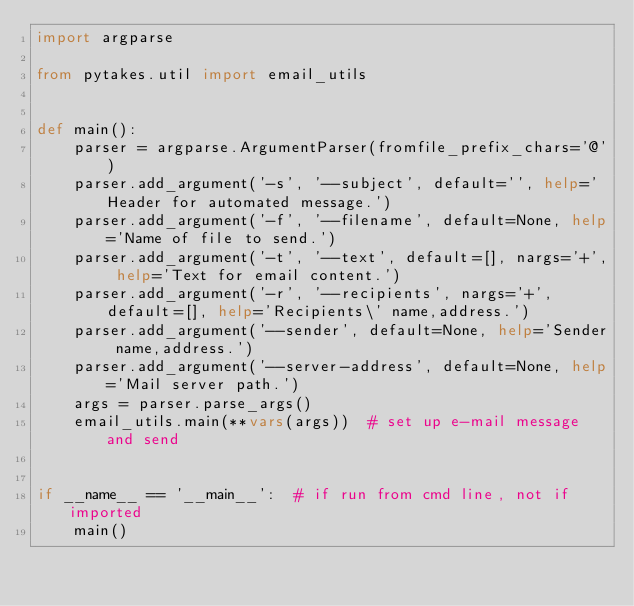Convert code to text. <code><loc_0><loc_0><loc_500><loc_500><_Python_>import argparse

from pytakes.util import email_utils


def main():
    parser = argparse.ArgumentParser(fromfile_prefix_chars='@')
    parser.add_argument('-s', '--subject', default='', help='Header for automated message.')
    parser.add_argument('-f', '--filename', default=None, help='Name of file to send.')
    parser.add_argument('-t', '--text', default=[], nargs='+', help='Text for email content.')
    parser.add_argument('-r', '--recipients', nargs='+', default=[], help='Recipients\' name,address.')
    parser.add_argument('--sender', default=None, help='Sender name,address.')
    parser.add_argument('--server-address', default=None, help='Mail server path.')
    args = parser.parse_args()
    email_utils.main(**vars(args))  # set up e-mail message and send


if __name__ == '__main__':  # if run from cmd line, not if imported
    main()
</code> 